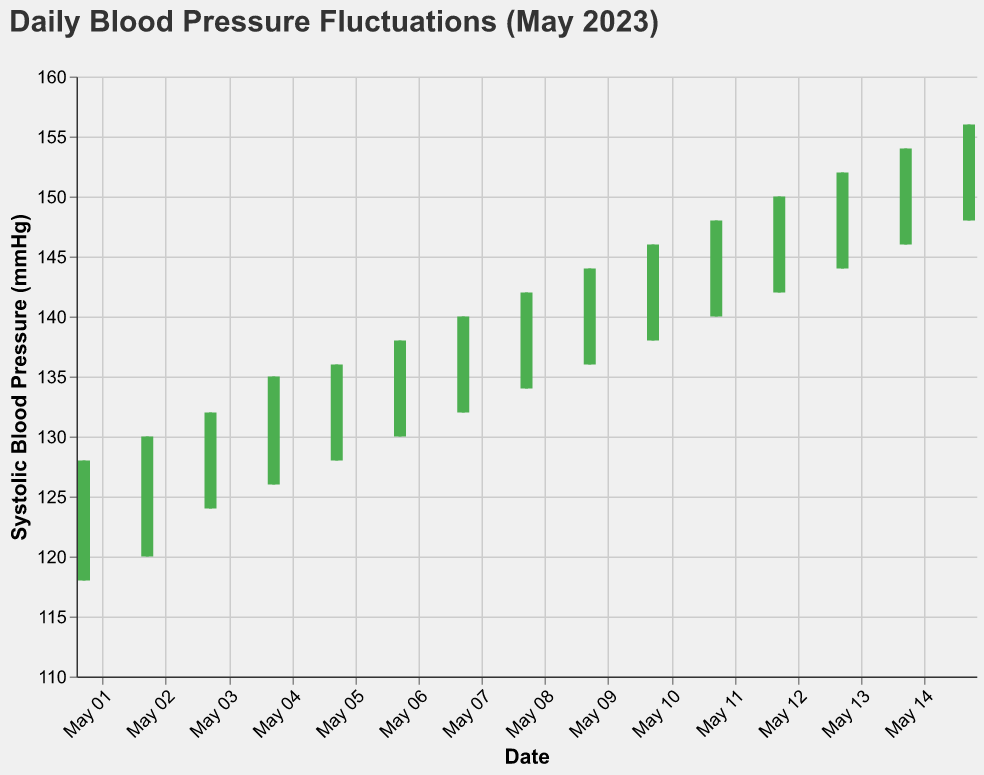What's the title of the chart? The title is located at the top of the figure and is usually the biggest text. It gives a summary of what the chart represents.
Answer: Daily Blood Pressure Fluctuations (May 2023) How many days are represented in this chart? The number of days can be counted by looking at the x-axis, which lists the dates in May from 1st to 15th. Each tick on the x-axis corresponds to a day.
Answer: 15 On which date did the highest systolic blood pressure occur? To find the highest systolic blood pressure, you need to look for the highest "High" value marked by the top endpoint of the vertical rule segment of the bar. The date corresponding to this endpoint is May 15th, which has a "High" value of 156 mmHg.
Answer: May 15 What was the systolic blood pressure range on May 5th? The systolic blood pressure range can be found by looking at the "High" and "Low" values on May 5th. The high was 136 mmHg, and the low was 128 mmHg.
Answer: 128-136 mmHg Which day showed the largest fluctuation between the high and low systolic values? Fluctuation is the difference between the high and low values. You calculate this for each day and compare. May 15 has a "High" of 156 and "Low" of 148, which makes a fluctuation of 8 mmHg, the largest in the provided days.
Answer: May 15 On which day did the systolic blood pressure decrease by the most amount from the morning to the evening? Decrease happens when the "Open" (morning) value is higher than the "Close" (evening) value. The largest decrease can be found by calculating the difference. May 8 shows an "Open" of 137 and a "Close" of 139; no decrement is greater than this shift in the dataset.
Answer: No decrease observed in provided data Which days saw an overall increase in systolic blood pressure from morning to evening? An increase is signaled by a green bar, where the "Open" (morning) value is lower than the "Close" (evening) value. Checking each day, days like May 1, 2, 3, etc., exhibit this condition.
Answer: May 1, May 2, May 3, May 4, May 5, May 6, May 7, May 8, May 9, May 10, May 11, May 12, May 13, May 14, May 15 What is the median value of the daily closing systolic blood pressures for the data provided? To find the median, list all closing systolic values, sort them, and find the center. For May 1 to 15: 80, 82, 83, 85, 86, 88, 89, 91, 92, 94, 95, 96, 97, 98, 99, the middle value in sorted order is 91.
Answer: 91 mmHg How does the systolic blood pressure trend from the beginning to the end of the month? Look at the closing values from May 1 to May 15. There is a significant upward trend as values rise from 125/80 to 153/99, showing an increasing trend in the systolic blood pressure overall.
Answer: Upward trend What was the lowest systolic blood pressure recorded in the month of May? The lowest systolic pressure can be found by looking for the lowest "Low" value across all days. This value is found on May 1st, which is 118 mmHg.
Answer: 118 mmHg 